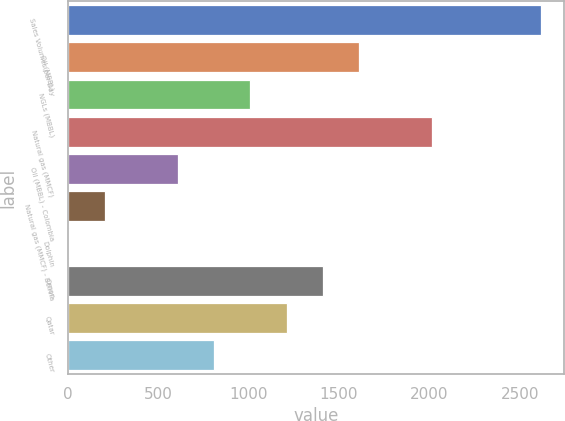Convert chart. <chart><loc_0><loc_0><loc_500><loc_500><bar_chart><fcel>Sales Volumes per Day<fcel>Oil (MBBL)<fcel>NGLs (MBBL)<fcel>Natural gas (MMCF)<fcel>Oil (MBBL) - Colombia<fcel>Natural gas (MMCF) - Bolivia<fcel>Dolphin<fcel>Oman<fcel>Qatar<fcel>Other<nl><fcel>2615.1<fcel>1611.6<fcel>1009.5<fcel>2013<fcel>608.1<fcel>206.7<fcel>6<fcel>1410.9<fcel>1210.2<fcel>808.8<nl></chart> 